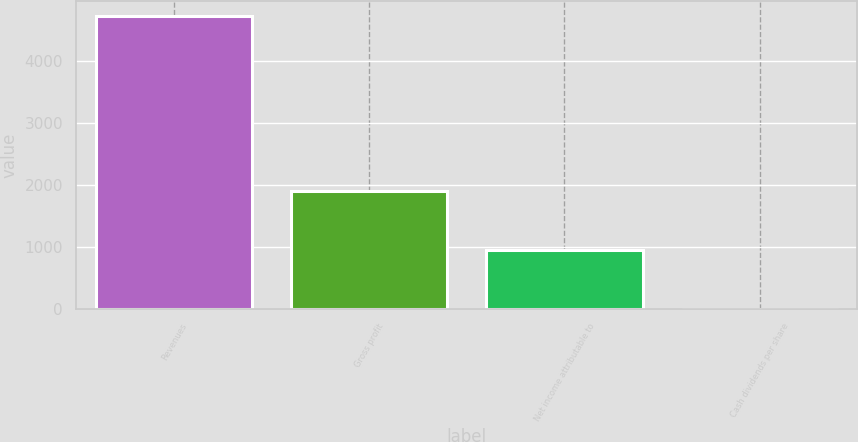Convert chart to OTSL. <chart><loc_0><loc_0><loc_500><loc_500><bar_chart><fcel>Revenues<fcel>Gross profit<fcel>Net income attributable to<fcel>Cash dividends per share<nl><fcel>4734<fcel>1893.68<fcel>946.9<fcel>0.12<nl></chart> 